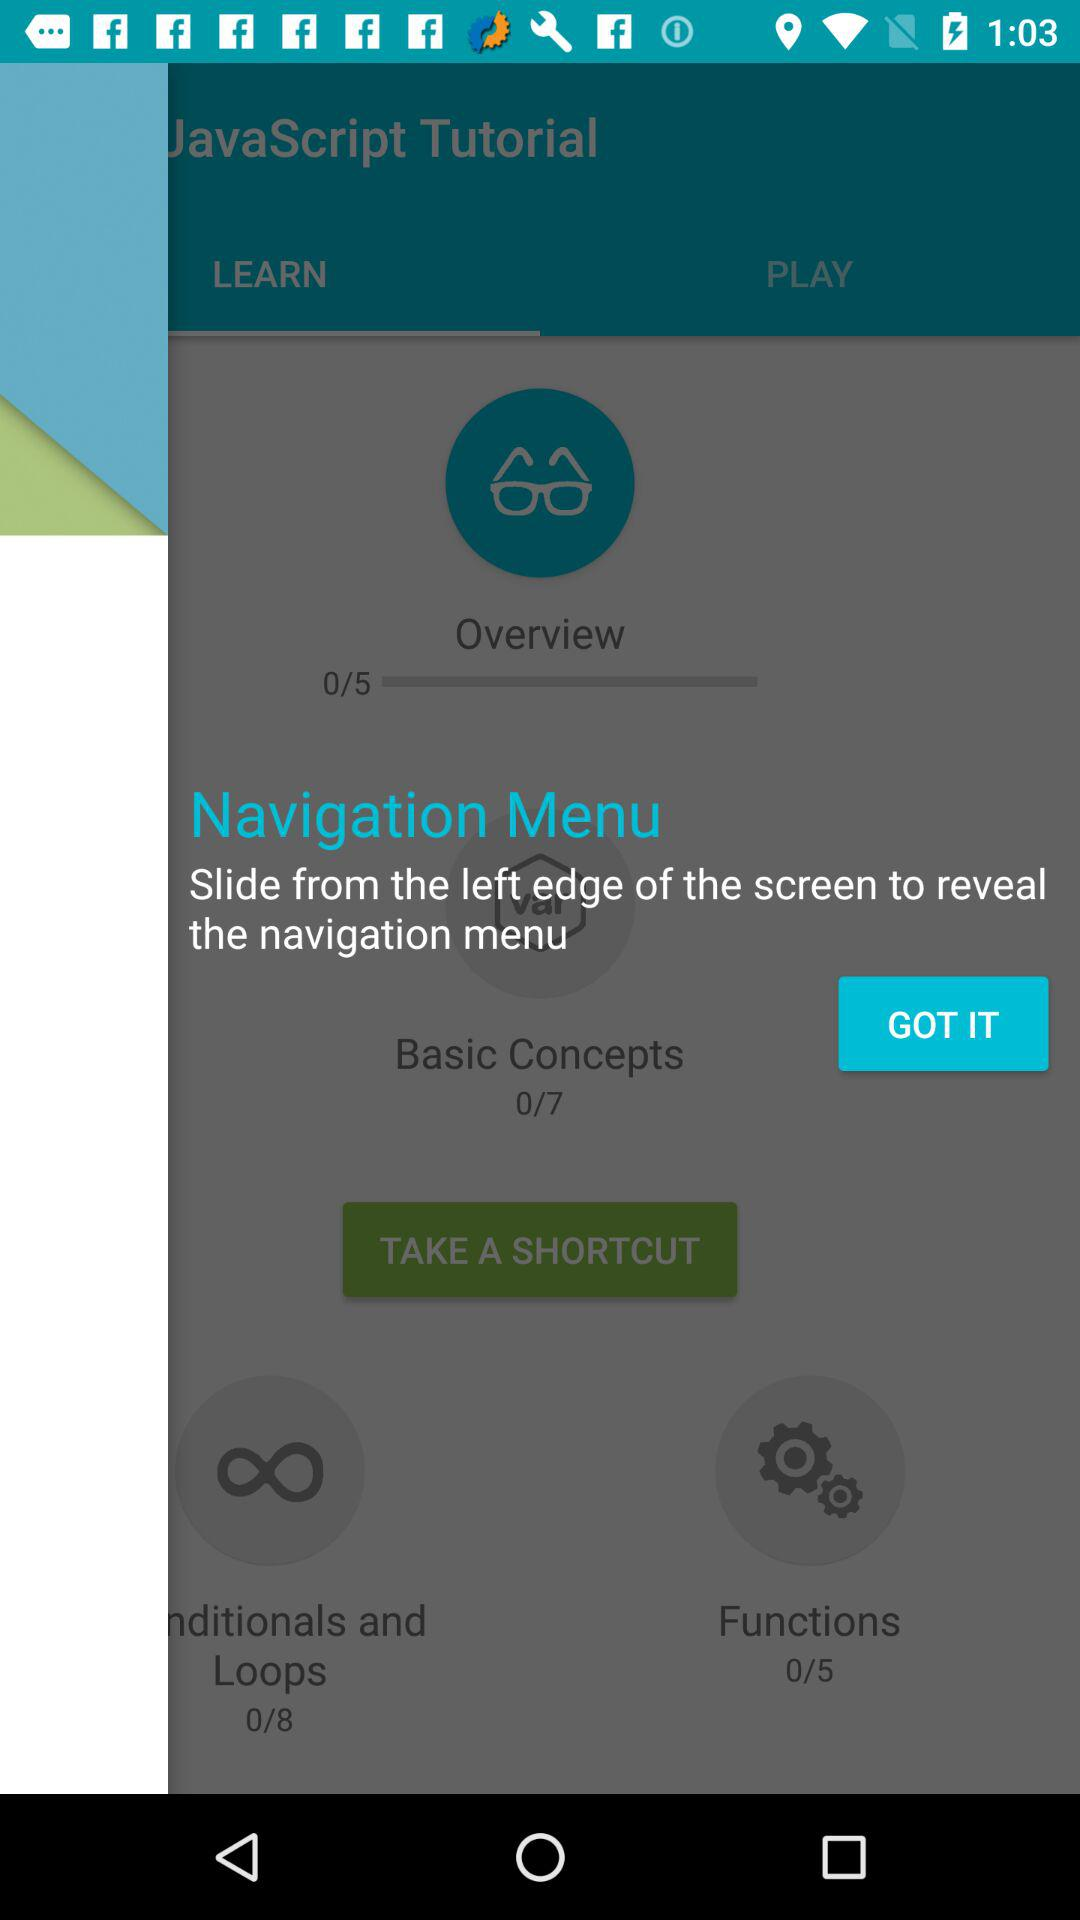What is the total number of functions? The total number of functions is 5. 